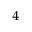Convert formula to latex. <formula><loc_0><loc_0><loc_500><loc_500>^ { 4 }</formula> 